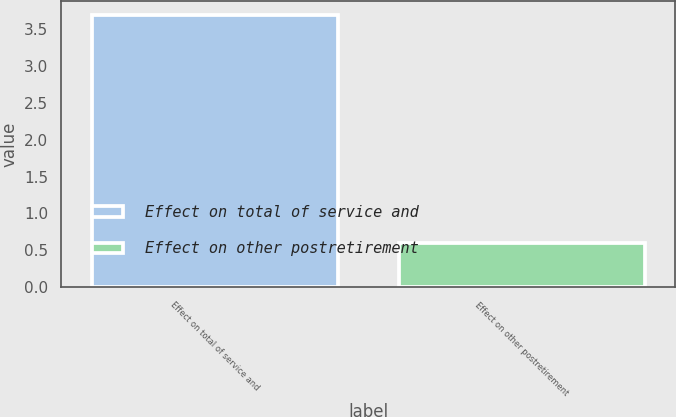Convert chart to OTSL. <chart><loc_0><loc_0><loc_500><loc_500><bar_chart><fcel>Effect on total of service and<fcel>Effect on other postretirement<nl><fcel>3.7<fcel>0.6<nl></chart> 